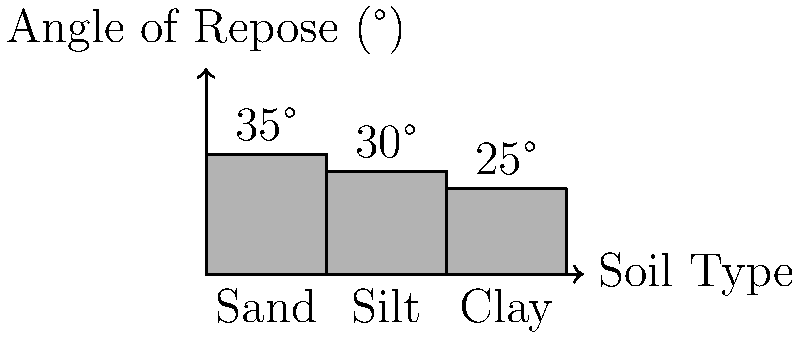Based on the graph showing the angles of repose for different soil types, which soil would be most susceptible to slope failure during excavation, and what measure should be taken to ensure stability? To determine which soil is most susceptible to slope failure and how to ensure stability, we need to analyze the given information:

1. The graph shows the angle of repose for three soil types: Sand (35°), Silt (30°), and Clay (25°).

2. The angle of repose is the steepest angle at which a material can be piled without slumping. A lower angle of repose indicates that the material is less stable and more prone to sliding or flowing.

3. Comparing the angles:
   Sand: 35°
   Silt: 30°
   Clay: 25°

4. Clay has the lowest angle of repose at 25°, making it the most susceptible to slope failure during excavation.

5. To ensure stability, the excavation slope for clay should be less steep than its angle of repose. A common practice is to use a factor of safety by reducing the slope angle further.

6. For clay, a suitable measure would be to excavate at an angle significantly less than 25°, perhaps 15-20°, depending on site-specific conditions and engineering recommendations.

7. Additional measures may include:
   - Implementing proper drainage systems
   - Using retaining walls or other support structures
   - Conducting regular slope stability assessments
Answer: Clay; excavate at an angle less than 25° (e.g., 15-20°) 